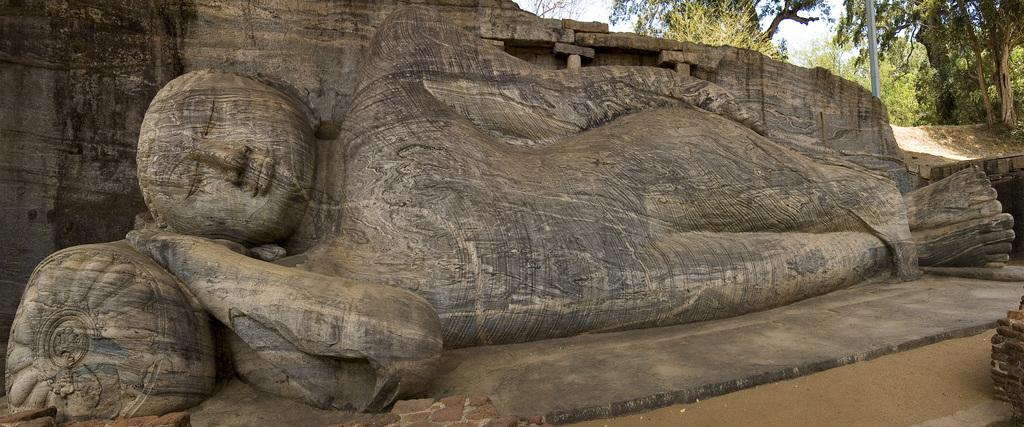What type of statue can be seen in the image? There is an ancient statue of a goddess in the image. What is located on the right side of the image? There are trees on the right side of the image. What object is present in the image that might be used for support or attachment? There is a pole in the image. What is visible in the background of the image? The sky is visible in the image. What type of terrain is depicted in the image? The ground appears to be sand. What type of soup is being served in the image? There is no soup present in the image; it features an ancient statue of a goddess, trees, a pole, the sky, and sandy ground. 